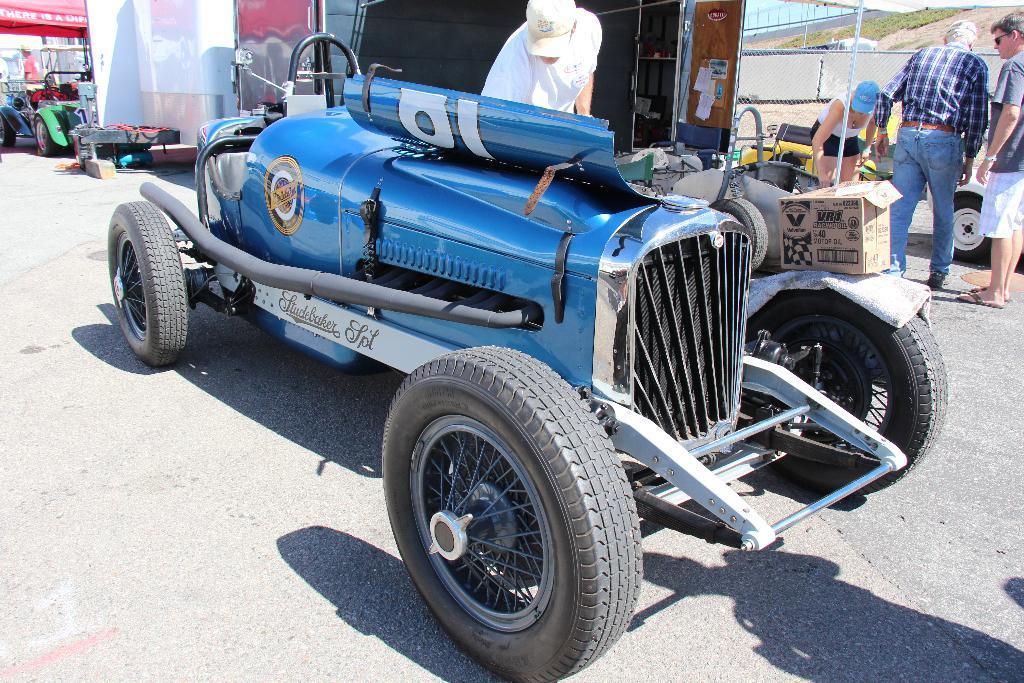In one or two sentences, can you explain what this image depicts? In this picture I can see a vehicle in front and I see that it is on the road. I can also see a cloth and a box on a wheel. Behind the vehicle I can see a person wearing a cap. On the right side of this image I can see 2 men and a woman and I can see few things near to them. On the left side of this image I can see another vehicle and I can see few cardboard on the top side of this picture. 